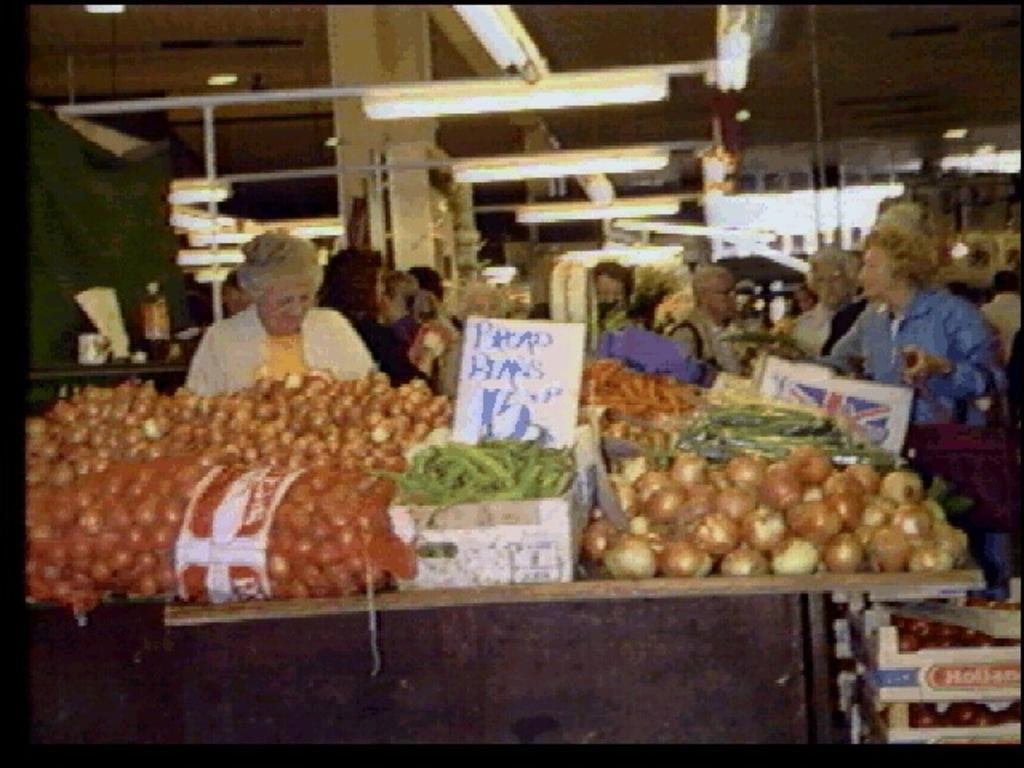What can be seen in the image involving people? There are people standing in the image. What type of food items are visible in the image? There are vegetables in the image. What kind of structures are present in the image? There are boards in the image. What can be seen providing illumination in the image? There are lights in the image. Can you describe any other objects present in the image? There are other objects present in the image, but their specific nature is not mentioned in the provided facts. How many books are visible on the stomach of the person in the image? There are no books visible on the stomach of any person in the image. What type of room is depicted in the image? The provided facts do not mention any room or specific setting for the image. 